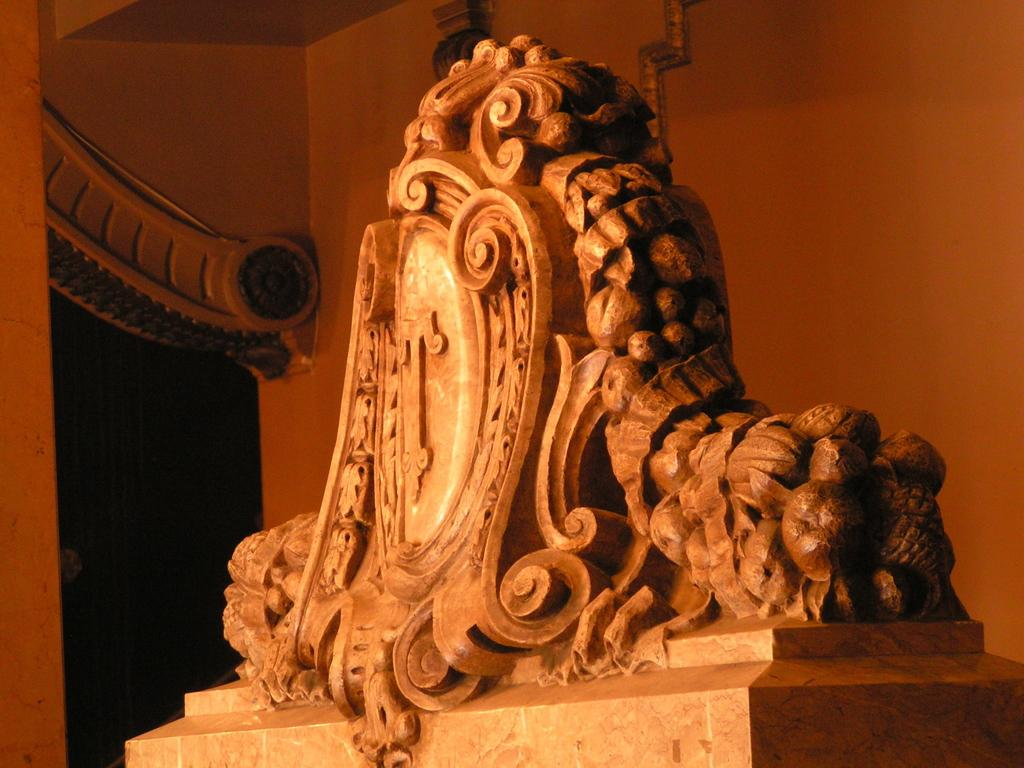What is the main subject in the image? There is a sculpture in the image. How is the sculpture supported or displayed? The sculpture is on a stand. What can be seen in the background of the image? There are walls visible in the background of the image. Are there any other objects or features in the background? Yes, there are objects present in the background of the image. How does the sculpture maintain its balance in the snow? There is no snow present in the image, and the sculpture is already on a stand for support. 